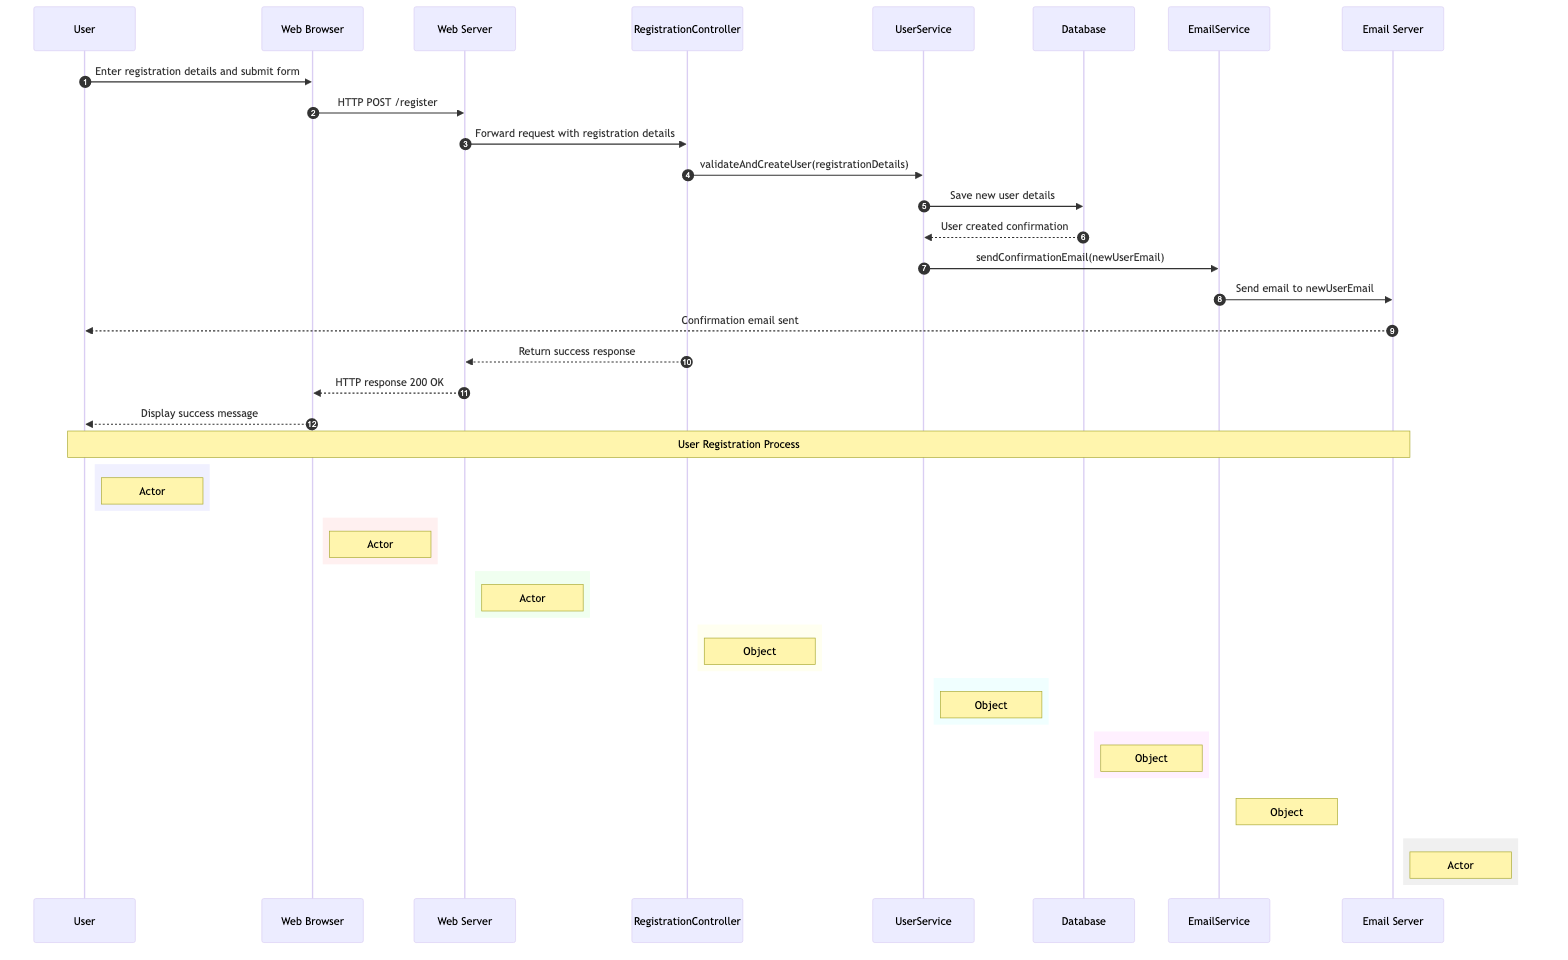What is the first action taken by the User? The diagram shows that the first action taken by the User is to enter registration details and submit the form, represented as a message from User to Web Browser.
Answer: Enter registration details and submit form How many actors are represented in the diagram? By counting the participants listed as actors in the diagram, we find that there are five actors involved: User, Web Browser, Web Server, Application, and Email Server.
Answer: 5 What request is sent from the Web Browser to the Web Server? The message indicates that the Web Browser sends an HTTP POST request to the Web Server with the endpoint /register.
Answer: HTTP POST /register Which object is responsible for validating user details? Upon examining the messages, it's clear that the RegistrationController communicates with the UserService to validate and create a user.
Answer: UserService What confirmation is sent after user details are saved? After saving new user details in the Database, the Database sends back a message to UserService saying "User created confirmation". This indicates the successful creation of a user.
Answer: User created confirmation Which service sends a confirmation email? The EmailService is the actor responsible for sending the confirmation email to the new user's email address. This action follows the message from UserService to EmailService to initiate the email sending process.
Answer: EmailService What status does the Web Server return after processing the registration? The Web Server returns a success response after receiving the confirmation from RegistrationController, which is represented by "HTTP response 200 OK".
Answer: HTTP response 200 OK How is the success message displayed to the User? The Web Browser receives the "HTTP response 200 OK" from the Web Server and then proceeds to display a success message to the User, confirming the registration process has completed.
Answer: Display success message In the sequence of actions, which entity is the last to communicate with the User? The last entity to communicate with the User is the Email Server, which sends the confirmation email through a message labeled "Confirmation email sent" before the success message is displayed.
Answer: Email Server 